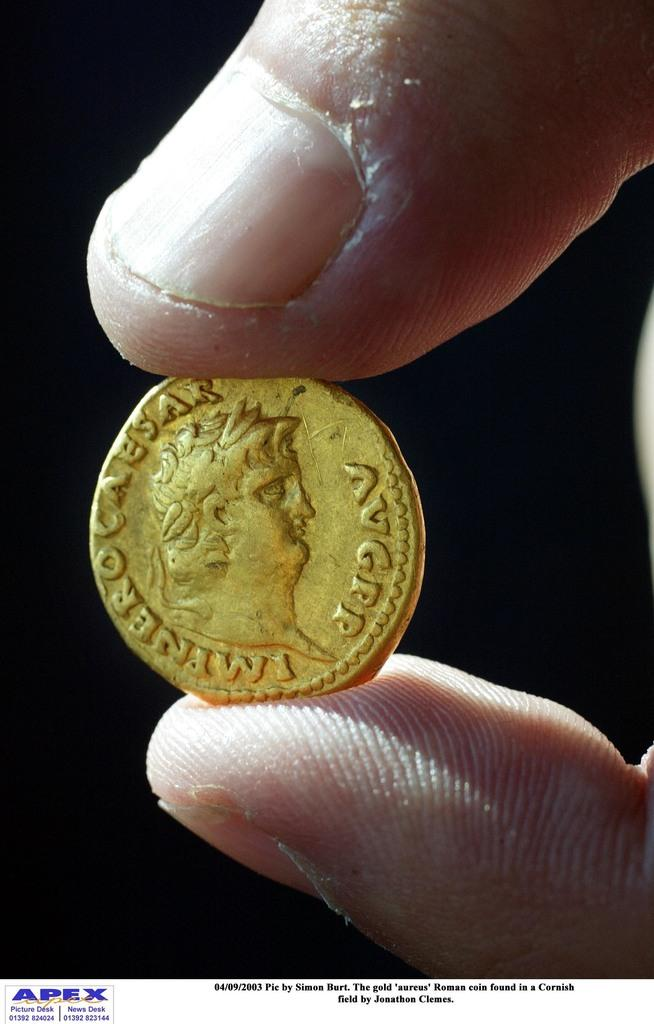<image>
Render a clear and concise summary of the photo. an ancient looking gold coin with the word Caesar on it 